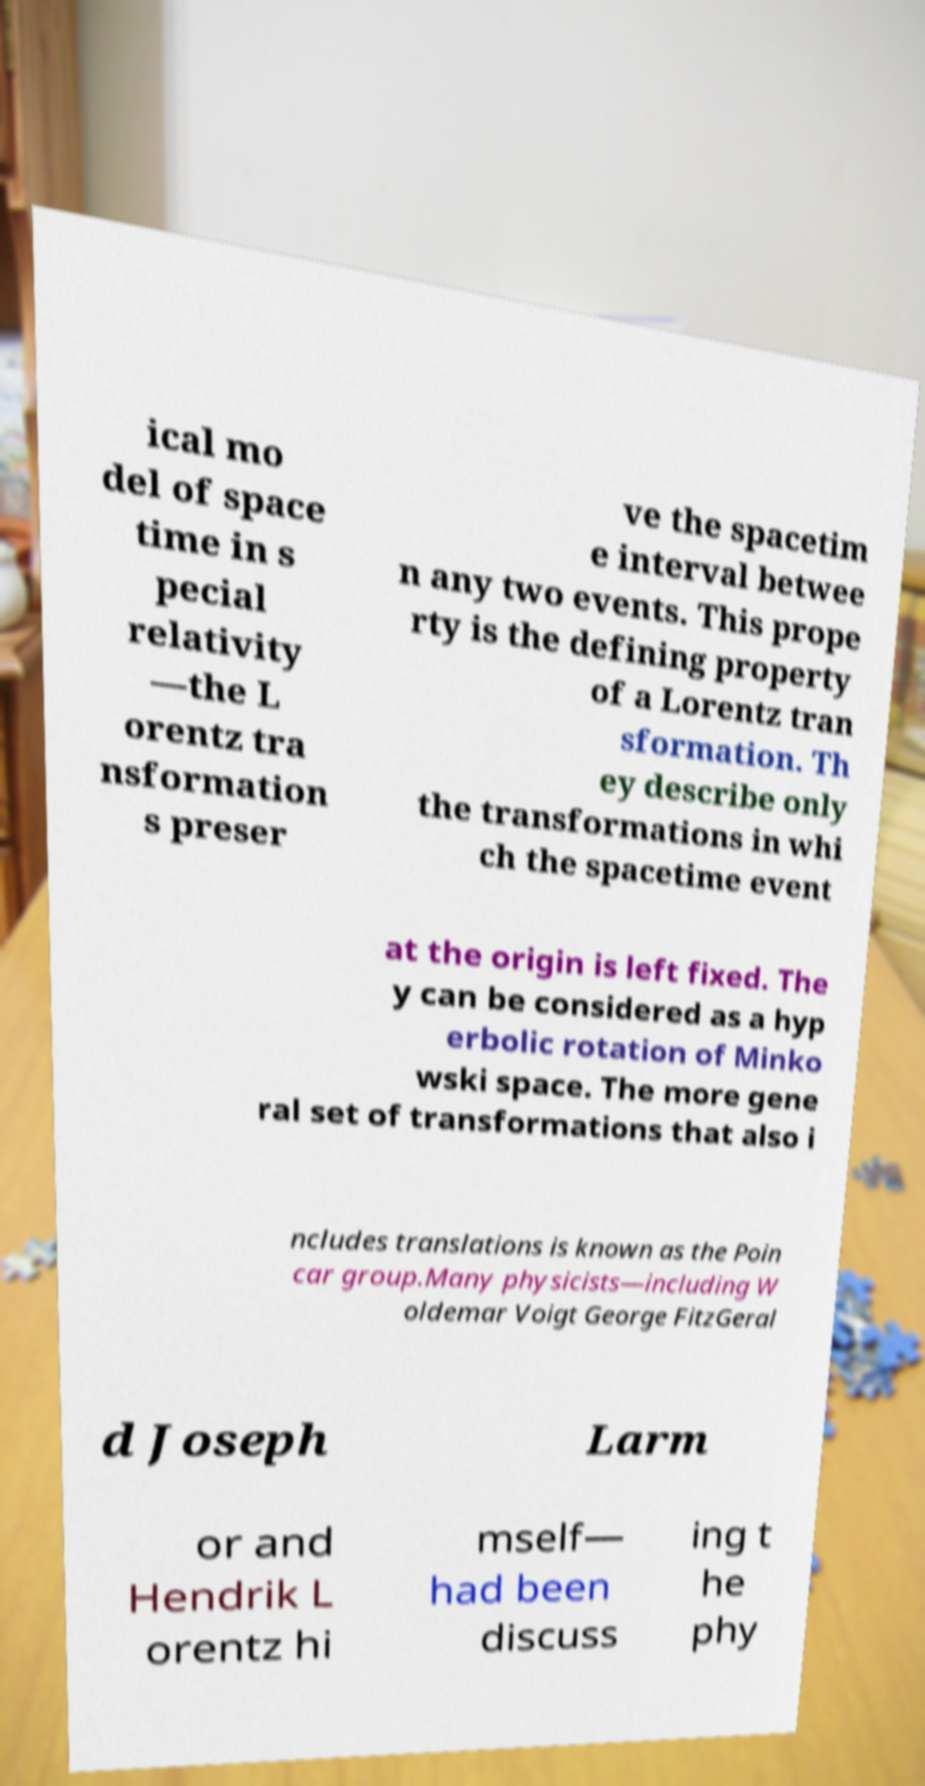There's text embedded in this image that I need extracted. Can you transcribe it verbatim? ical mo del of space time in s pecial relativity —the L orentz tra nsformation s preser ve the spacetim e interval betwee n any two events. This prope rty is the defining property of a Lorentz tran sformation. Th ey describe only the transformations in whi ch the spacetime event at the origin is left fixed. The y can be considered as a hyp erbolic rotation of Minko wski space. The more gene ral set of transformations that also i ncludes translations is known as the Poin car group.Many physicists—including W oldemar Voigt George FitzGeral d Joseph Larm or and Hendrik L orentz hi mself— had been discuss ing t he phy 